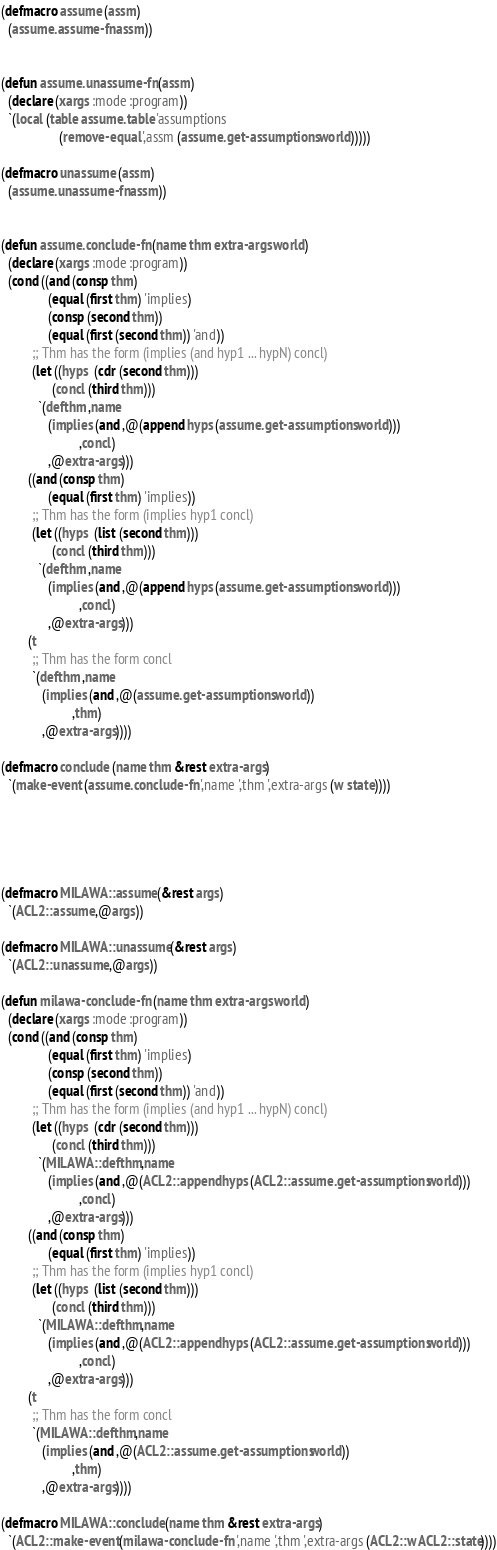<code> <loc_0><loc_0><loc_500><loc_500><_Lisp_>(defmacro assume (assm)
  (assume.assume-fn assm))


(defun assume.unassume-fn (assm)
  (declare (xargs :mode :program))
  `(local (table assume.table 'assumptions
                 (remove-equal ',assm (assume.get-assumptions world)))))

(defmacro unassume (assm)
  (assume.unassume-fn assm))


(defun assume.conclude-fn (name thm extra-args world)
  (declare (xargs :mode :program))
  (cond ((and (consp thm)
              (equal (first thm) 'implies)
              (consp (second thm))
              (equal (first (second thm)) 'and))
         ;; Thm has the form (implies (and hyp1 ... hypN) concl)
         (let ((hyps  (cdr (second thm)))
               (concl (third thm)))
           `(defthm ,name
              (implies (and ,@(append hyps (assume.get-assumptions world)))
                       ,concl)
              ,@extra-args)))
        ((and (consp thm)
              (equal (first thm) 'implies))
         ;; Thm has the form (implies hyp1 concl)
         (let ((hyps  (list (second thm)))
               (concl (third thm)))
           `(defthm ,name
              (implies (and ,@(append hyps (assume.get-assumptions world)))
                       ,concl)
              ,@extra-args)))
        (t
         ;; Thm has the form concl
         `(defthm ,name
            (implies (and ,@(assume.get-assumptions world))
                     ,thm)
            ,@extra-args))))

(defmacro conclude (name thm &rest extra-args)
  `(make-event (assume.conclude-fn ',name ',thm ',extra-args (w state))))





(defmacro MILAWA::assume (&rest args)
  `(ACL2::assume ,@args))

(defmacro MILAWA::unassume (&rest args)
  `(ACL2::unassume ,@args))

(defun milawa-conclude-fn (name thm extra-args world)
  (declare (xargs :mode :program))
  (cond ((and (consp thm)
              (equal (first thm) 'implies)
              (consp (second thm))
              (equal (first (second thm)) 'and))
         ;; Thm has the form (implies (and hyp1 ... hypN) concl)
         (let ((hyps  (cdr (second thm)))
               (concl (third thm)))
           `(MILAWA::defthm ,name
              (implies (and ,@(ACL2::append hyps (ACL2::assume.get-assumptions world)))
                       ,concl)
              ,@extra-args)))
        ((and (consp thm)
              (equal (first thm) 'implies))
         ;; Thm has the form (implies hyp1 concl)
         (let ((hyps  (list (second thm)))
               (concl (third thm)))
           `(MILAWA::defthm ,name
              (implies (and ,@(ACL2::append hyps (ACL2::assume.get-assumptions world)))
                       ,concl)
              ,@extra-args)))
        (t
         ;; Thm has the form concl
         `(MILAWA::defthm ,name
            (implies (and ,@(ACL2::assume.get-assumptions world))
                     ,thm)
            ,@extra-args))))

(defmacro MILAWA::conclude (name thm &rest extra-args)
  `(ACL2::make-event (milawa-conclude-fn ',name ',thm ',extra-args (ACL2::w ACL2::state))))

</code> 